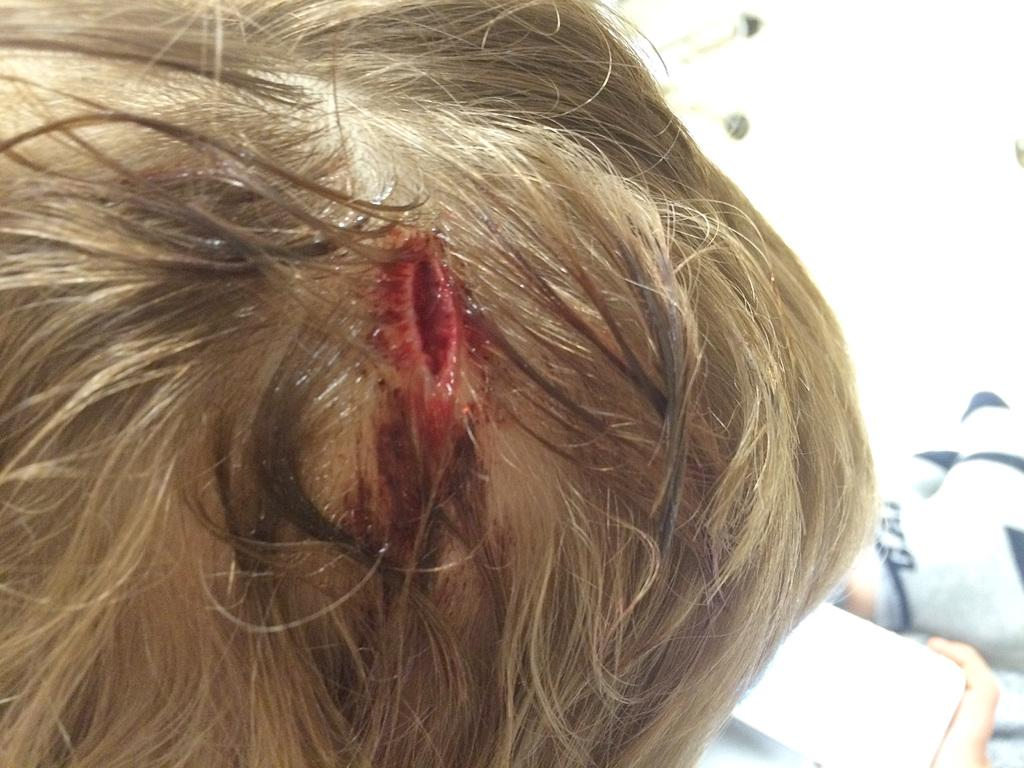What is the main subject of the image? There is a person in the image. What is the person holding in the image? The person is holding a mobile. Can you describe the person's appearance in the image? The person has an injury on his head. What type of machine is being used in the meeting in the image? There is no machine or meeting present in the image; it features a person holding a mobile with an injury on his head. 